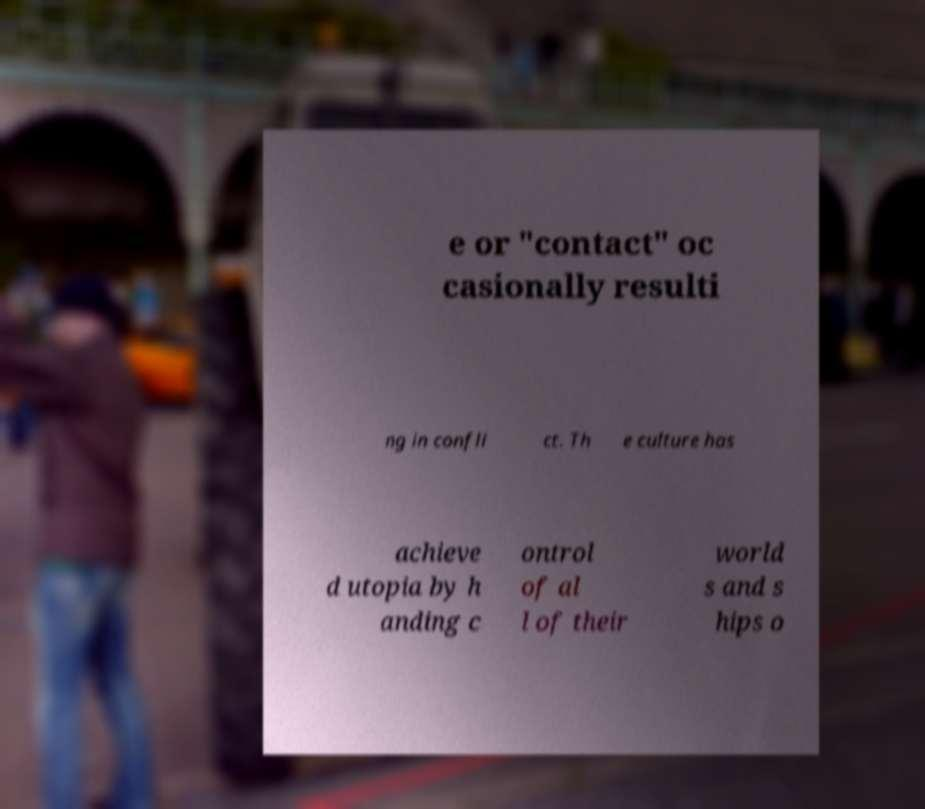I need the written content from this picture converted into text. Can you do that? e or "contact" oc casionally resulti ng in confli ct. Th e culture has achieve d utopia by h anding c ontrol of al l of their world s and s hips o 